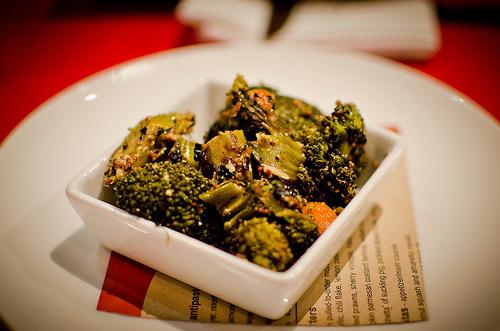Question: why are the specs on the food?
Choices:
A. Spices.
B. Ash from the grill.
C. Frosting.
D. Decoration.
Answer with the letter. Answer: A Question: what is white?
Choices:
A. Plate.
B. The house.
C. The walls.
D. The vase.
Answer with the letter. Answer: A Question: what is green?
Choices:
A. Apples.
B. Money.
C. Broccoli.
D. The grass.
Answer with the letter. Answer: C Question: where is the bowl sitting?
Choices:
A. On the coffee table.
B. On a plate.
C. On the counter.
D. On the dining table.
Answer with the letter. Answer: B Question: what is red?
Choices:
A. Tablecloth.
B. The blanket.
C. The car.
D. The shirt.
Answer with the letter. Answer: A 